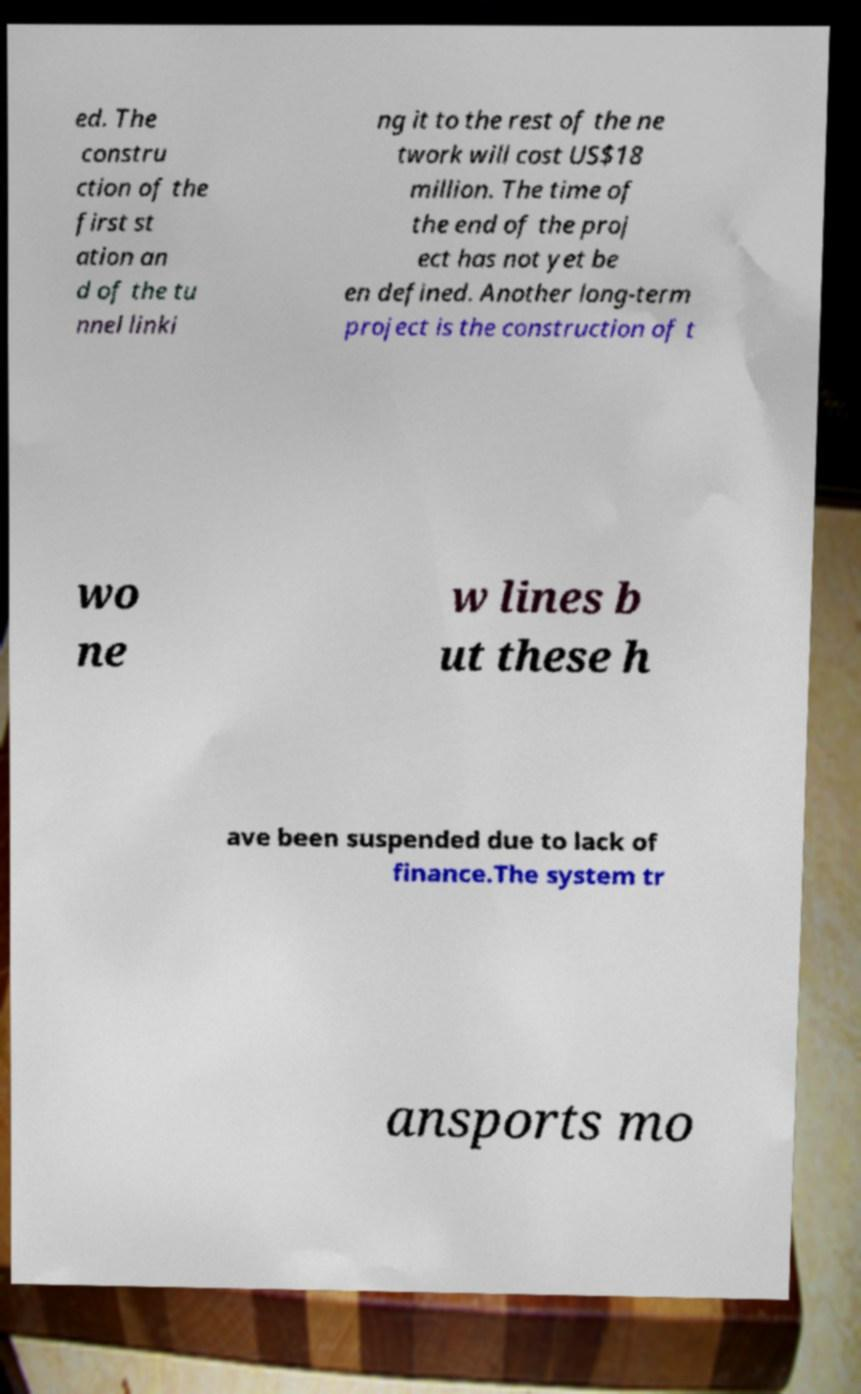I need the written content from this picture converted into text. Can you do that? ed. The constru ction of the first st ation an d of the tu nnel linki ng it to the rest of the ne twork will cost US$18 million. The time of the end of the proj ect has not yet be en defined. Another long-term project is the construction of t wo ne w lines b ut these h ave been suspended due to lack of finance.The system tr ansports mo 